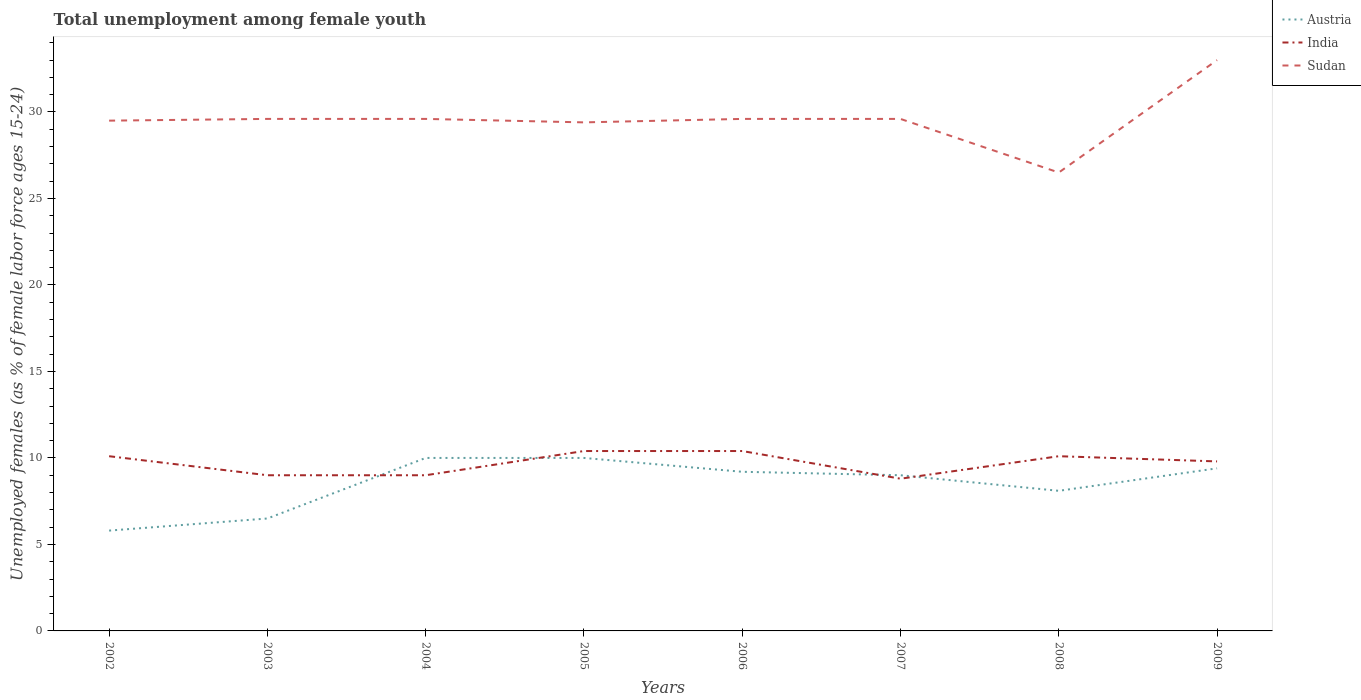How many different coloured lines are there?
Your response must be concise. 3. Is the number of lines equal to the number of legend labels?
Your answer should be very brief. Yes. Across all years, what is the maximum percentage of unemployed females in in Austria?
Offer a terse response. 5.8. What is the total percentage of unemployed females in in India in the graph?
Keep it short and to the point. 1.3. What is the difference between the highest and the second highest percentage of unemployed females in in Sudan?
Keep it short and to the point. 6.5. What is the difference between the highest and the lowest percentage of unemployed females in in India?
Keep it short and to the point. 5. What is the difference between two consecutive major ticks on the Y-axis?
Ensure brevity in your answer.  5. What is the title of the graph?
Provide a succinct answer. Total unemployment among female youth. Does "Japan" appear as one of the legend labels in the graph?
Your answer should be very brief. No. What is the label or title of the Y-axis?
Give a very brief answer. Unemployed females (as % of female labor force ages 15-24). What is the Unemployed females (as % of female labor force ages 15-24) of Austria in 2002?
Your answer should be compact. 5.8. What is the Unemployed females (as % of female labor force ages 15-24) in India in 2002?
Ensure brevity in your answer.  10.1. What is the Unemployed females (as % of female labor force ages 15-24) in Sudan in 2002?
Provide a short and direct response. 29.5. What is the Unemployed females (as % of female labor force ages 15-24) of India in 2003?
Provide a succinct answer. 9. What is the Unemployed females (as % of female labor force ages 15-24) of Sudan in 2003?
Provide a succinct answer. 29.6. What is the Unemployed females (as % of female labor force ages 15-24) of Austria in 2004?
Give a very brief answer. 10. What is the Unemployed females (as % of female labor force ages 15-24) in Sudan in 2004?
Ensure brevity in your answer.  29.6. What is the Unemployed females (as % of female labor force ages 15-24) of India in 2005?
Provide a short and direct response. 10.4. What is the Unemployed females (as % of female labor force ages 15-24) in Sudan in 2005?
Your answer should be very brief. 29.4. What is the Unemployed females (as % of female labor force ages 15-24) of Austria in 2006?
Offer a very short reply. 9.2. What is the Unemployed females (as % of female labor force ages 15-24) of India in 2006?
Provide a short and direct response. 10.4. What is the Unemployed females (as % of female labor force ages 15-24) of Sudan in 2006?
Your answer should be compact. 29.6. What is the Unemployed females (as % of female labor force ages 15-24) in India in 2007?
Provide a short and direct response. 8.8. What is the Unemployed females (as % of female labor force ages 15-24) of Sudan in 2007?
Offer a very short reply. 29.6. What is the Unemployed females (as % of female labor force ages 15-24) in Austria in 2008?
Your answer should be compact. 8.1. What is the Unemployed females (as % of female labor force ages 15-24) of India in 2008?
Make the answer very short. 10.1. What is the Unemployed females (as % of female labor force ages 15-24) in Sudan in 2008?
Your answer should be very brief. 26.5. What is the Unemployed females (as % of female labor force ages 15-24) of Austria in 2009?
Offer a terse response. 9.4. What is the Unemployed females (as % of female labor force ages 15-24) in India in 2009?
Offer a terse response. 9.8. What is the Unemployed females (as % of female labor force ages 15-24) of Sudan in 2009?
Offer a very short reply. 33. Across all years, what is the maximum Unemployed females (as % of female labor force ages 15-24) of Austria?
Give a very brief answer. 10. Across all years, what is the maximum Unemployed females (as % of female labor force ages 15-24) in India?
Your answer should be very brief. 10.4. Across all years, what is the minimum Unemployed females (as % of female labor force ages 15-24) in Austria?
Offer a terse response. 5.8. Across all years, what is the minimum Unemployed females (as % of female labor force ages 15-24) of India?
Keep it short and to the point. 8.8. Across all years, what is the minimum Unemployed females (as % of female labor force ages 15-24) in Sudan?
Your answer should be very brief. 26.5. What is the total Unemployed females (as % of female labor force ages 15-24) in India in the graph?
Keep it short and to the point. 77.6. What is the total Unemployed females (as % of female labor force ages 15-24) of Sudan in the graph?
Ensure brevity in your answer.  236.8. What is the difference between the Unemployed females (as % of female labor force ages 15-24) in India in 2002 and that in 2003?
Ensure brevity in your answer.  1.1. What is the difference between the Unemployed females (as % of female labor force ages 15-24) in Sudan in 2002 and that in 2003?
Make the answer very short. -0.1. What is the difference between the Unemployed females (as % of female labor force ages 15-24) in India in 2002 and that in 2004?
Your answer should be very brief. 1.1. What is the difference between the Unemployed females (as % of female labor force ages 15-24) in Sudan in 2002 and that in 2004?
Your response must be concise. -0.1. What is the difference between the Unemployed females (as % of female labor force ages 15-24) in Austria in 2002 and that in 2005?
Provide a short and direct response. -4.2. What is the difference between the Unemployed females (as % of female labor force ages 15-24) of Sudan in 2002 and that in 2006?
Offer a very short reply. -0.1. What is the difference between the Unemployed females (as % of female labor force ages 15-24) of Austria in 2002 and that in 2007?
Your response must be concise. -3.2. What is the difference between the Unemployed females (as % of female labor force ages 15-24) of Sudan in 2002 and that in 2007?
Offer a terse response. -0.1. What is the difference between the Unemployed females (as % of female labor force ages 15-24) of Austria in 2002 and that in 2008?
Offer a terse response. -2.3. What is the difference between the Unemployed females (as % of female labor force ages 15-24) in Austria in 2002 and that in 2009?
Make the answer very short. -3.6. What is the difference between the Unemployed females (as % of female labor force ages 15-24) in Sudan in 2002 and that in 2009?
Your answer should be very brief. -3.5. What is the difference between the Unemployed females (as % of female labor force ages 15-24) in Sudan in 2003 and that in 2004?
Keep it short and to the point. 0. What is the difference between the Unemployed females (as % of female labor force ages 15-24) in Austria in 2003 and that in 2005?
Make the answer very short. -3.5. What is the difference between the Unemployed females (as % of female labor force ages 15-24) in Sudan in 2003 and that in 2005?
Offer a terse response. 0.2. What is the difference between the Unemployed females (as % of female labor force ages 15-24) of India in 2003 and that in 2006?
Give a very brief answer. -1.4. What is the difference between the Unemployed females (as % of female labor force ages 15-24) of Sudan in 2003 and that in 2006?
Make the answer very short. 0. What is the difference between the Unemployed females (as % of female labor force ages 15-24) of India in 2003 and that in 2008?
Your response must be concise. -1.1. What is the difference between the Unemployed females (as % of female labor force ages 15-24) of Austria in 2003 and that in 2009?
Offer a terse response. -2.9. What is the difference between the Unemployed females (as % of female labor force ages 15-24) of Sudan in 2004 and that in 2005?
Give a very brief answer. 0.2. What is the difference between the Unemployed females (as % of female labor force ages 15-24) in Austria in 2004 and that in 2006?
Give a very brief answer. 0.8. What is the difference between the Unemployed females (as % of female labor force ages 15-24) in Sudan in 2004 and that in 2007?
Offer a terse response. 0. What is the difference between the Unemployed females (as % of female labor force ages 15-24) in Austria in 2004 and that in 2008?
Your answer should be very brief. 1.9. What is the difference between the Unemployed females (as % of female labor force ages 15-24) in India in 2004 and that in 2008?
Your response must be concise. -1.1. What is the difference between the Unemployed females (as % of female labor force ages 15-24) of Sudan in 2004 and that in 2008?
Your answer should be compact. 3.1. What is the difference between the Unemployed females (as % of female labor force ages 15-24) of Sudan in 2004 and that in 2009?
Offer a very short reply. -3.4. What is the difference between the Unemployed females (as % of female labor force ages 15-24) in India in 2005 and that in 2006?
Ensure brevity in your answer.  0. What is the difference between the Unemployed females (as % of female labor force ages 15-24) of Sudan in 2005 and that in 2006?
Make the answer very short. -0.2. What is the difference between the Unemployed females (as % of female labor force ages 15-24) in Austria in 2005 and that in 2007?
Your answer should be very brief. 1. What is the difference between the Unemployed females (as % of female labor force ages 15-24) of India in 2005 and that in 2007?
Ensure brevity in your answer.  1.6. What is the difference between the Unemployed females (as % of female labor force ages 15-24) of India in 2005 and that in 2008?
Your answer should be compact. 0.3. What is the difference between the Unemployed females (as % of female labor force ages 15-24) of Sudan in 2005 and that in 2008?
Provide a short and direct response. 2.9. What is the difference between the Unemployed females (as % of female labor force ages 15-24) in Sudan in 2005 and that in 2009?
Your answer should be compact. -3.6. What is the difference between the Unemployed females (as % of female labor force ages 15-24) of Austria in 2006 and that in 2008?
Ensure brevity in your answer.  1.1. What is the difference between the Unemployed females (as % of female labor force ages 15-24) of India in 2006 and that in 2008?
Your response must be concise. 0.3. What is the difference between the Unemployed females (as % of female labor force ages 15-24) in Sudan in 2006 and that in 2008?
Give a very brief answer. 3.1. What is the difference between the Unemployed females (as % of female labor force ages 15-24) in Austria in 2006 and that in 2009?
Give a very brief answer. -0.2. What is the difference between the Unemployed females (as % of female labor force ages 15-24) in India in 2006 and that in 2009?
Give a very brief answer. 0.6. What is the difference between the Unemployed females (as % of female labor force ages 15-24) of Sudan in 2006 and that in 2009?
Your answer should be compact. -3.4. What is the difference between the Unemployed females (as % of female labor force ages 15-24) of India in 2007 and that in 2008?
Offer a very short reply. -1.3. What is the difference between the Unemployed females (as % of female labor force ages 15-24) in Sudan in 2007 and that in 2008?
Provide a succinct answer. 3.1. What is the difference between the Unemployed females (as % of female labor force ages 15-24) of Austria in 2007 and that in 2009?
Give a very brief answer. -0.4. What is the difference between the Unemployed females (as % of female labor force ages 15-24) in India in 2007 and that in 2009?
Offer a very short reply. -1. What is the difference between the Unemployed females (as % of female labor force ages 15-24) of Austria in 2008 and that in 2009?
Ensure brevity in your answer.  -1.3. What is the difference between the Unemployed females (as % of female labor force ages 15-24) of India in 2008 and that in 2009?
Give a very brief answer. 0.3. What is the difference between the Unemployed females (as % of female labor force ages 15-24) of Sudan in 2008 and that in 2009?
Your response must be concise. -6.5. What is the difference between the Unemployed females (as % of female labor force ages 15-24) in Austria in 2002 and the Unemployed females (as % of female labor force ages 15-24) in Sudan in 2003?
Give a very brief answer. -23.8. What is the difference between the Unemployed females (as % of female labor force ages 15-24) of India in 2002 and the Unemployed females (as % of female labor force ages 15-24) of Sudan in 2003?
Your answer should be compact. -19.5. What is the difference between the Unemployed females (as % of female labor force ages 15-24) of Austria in 2002 and the Unemployed females (as % of female labor force ages 15-24) of Sudan in 2004?
Make the answer very short. -23.8. What is the difference between the Unemployed females (as % of female labor force ages 15-24) of India in 2002 and the Unemployed females (as % of female labor force ages 15-24) of Sudan in 2004?
Make the answer very short. -19.5. What is the difference between the Unemployed females (as % of female labor force ages 15-24) of Austria in 2002 and the Unemployed females (as % of female labor force ages 15-24) of Sudan in 2005?
Make the answer very short. -23.6. What is the difference between the Unemployed females (as % of female labor force ages 15-24) in India in 2002 and the Unemployed females (as % of female labor force ages 15-24) in Sudan in 2005?
Provide a succinct answer. -19.3. What is the difference between the Unemployed females (as % of female labor force ages 15-24) in Austria in 2002 and the Unemployed females (as % of female labor force ages 15-24) in Sudan in 2006?
Your response must be concise. -23.8. What is the difference between the Unemployed females (as % of female labor force ages 15-24) in India in 2002 and the Unemployed females (as % of female labor force ages 15-24) in Sudan in 2006?
Your answer should be very brief. -19.5. What is the difference between the Unemployed females (as % of female labor force ages 15-24) in Austria in 2002 and the Unemployed females (as % of female labor force ages 15-24) in India in 2007?
Provide a short and direct response. -3. What is the difference between the Unemployed females (as % of female labor force ages 15-24) in Austria in 2002 and the Unemployed females (as % of female labor force ages 15-24) in Sudan in 2007?
Your response must be concise. -23.8. What is the difference between the Unemployed females (as % of female labor force ages 15-24) of India in 2002 and the Unemployed females (as % of female labor force ages 15-24) of Sudan in 2007?
Provide a short and direct response. -19.5. What is the difference between the Unemployed females (as % of female labor force ages 15-24) of Austria in 2002 and the Unemployed females (as % of female labor force ages 15-24) of India in 2008?
Offer a very short reply. -4.3. What is the difference between the Unemployed females (as % of female labor force ages 15-24) in Austria in 2002 and the Unemployed females (as % of female labor force ages 15-24) in Sudan in 2008?
Give a very brief answer. -20.7. What is the difference between the Unemployed females (as % of female labor force ages 15-24) of India in 2002 and the Unemployed females (as % of female labor force ages 15-24) of Sudan in 2008?
Provide a short and direct response. -16.4. What is the difference between the Unemployed females (as % of female labor force ages 15-24) in Austria in 2002 and the Unemployed females (as % of female labor force ages 15-24) in Sudan in 2009?
Keep it short and to the point. -27.2. What is the difference between the Unemployed females (as % of female labor force ages 15-24) of India in 2002 and the Unemployed females (as % of female labor force ages 15-24) of Sudan in 2009?
Ensure brevity in your answer.  -22.9. What is the difference between the Unemployed females (as % of female labor force ages 15-24) of Austria in 2003 and the Unemployed females (as % of female labor force ages 15-24) of India in 2004?
Your answer should be compact. -2.5. What is the difference between the Unemployed females (as % of female labor force ages 15-24) of Austria in 2003 and the Unemployed females (as % of female labor force ages 15-24) of Sudan in 2004?
Your answer should be very brief. -23.1. What is the difference between the Unemployed females (as % of female labor force ages 15-24) in India in 2003 and the Unemployed females (as % of female labor force ages 15-24) in Sudan in 2004?
Ensure brevity in your answer.  -20.6. What is the difference between the Unemployed females (as % of female labor force ages 15-24) in Austria in 2003 and the Unemployed females (as % of female labor force ages 15-24) in Sudan in 2005?
Provide a short and direct response. -22.9. What is the difference between the Unemployed females (as % of female labor force ages 15-24) of India in 2003 and the Unemployed females (as % of female labor force ages 15-24) of Sudan in 2005?
Keep it short and to the point. -20.4. What is the difference between the Unemployed females (as % of female labor force ages 15-24) in Austria in 2003 and the Unemployed females (as % of female labor force ages 15-24) in Sudan in 2006?
Make the answer very short. -23.1. What is the difference between the Unemployed females (as % of female labor force ages 15-24) of India in 2003 and the Unemployed females (as % of female labor force ages 15-24) of Sudan in 2006?
Your answer should be compact. -20.6. What is the difference between the Unemployed females (as % of female labor force ages 15-24) of Austria in 2003 and the Unemployed females (as % of female labor force ages 15-24) of India in 2007?
Ensure brevity in your answer.  -2.3. What is the difference between the Unemployed females (as % of female labor force ages 15-24) of Austria in 2003 and the Unemployed females (as % of female labor force ages 15-24) of Sudan in 2007?
Offer a terse response. -23.1. What is the difference between the Unemployed females (as % of female labor force ages 15-24) of India in 2003 and the Unemployed females (as % of female labor force ages 15-24) of Sudan in 2007?
Offer a very short reply. -20.6. What is the difference between the Unemployed females (as % of female labor force ages 15-24) of India in 2003 and the Unemployed females (as % of female labor force ages 15-24) of Sudan in 2008?
Offer a terse response. -17.5. What is the difference between the Unemployed females (as % of female labor force ages 15-24) in Austria in 2003 and the Unemployed females (as % of female labor force ages 15-24) in Sudan in 2009?
Keep it short and to the point. -26.5. What is the difference between the Unemployed females (as % of female labor force ages 15-24) in Austria in 2004 and the Unemployed females (as % of female labor force ages 15-24) in India in 2005?
Offer a very short reply. -0.4. What is the difference between the Unemployed females (as % of female labor force ages 15-24) in Austria in 2004 and the Unemployed females (as % of female labor force ages 15-24) in Sudan in 2005?
Give a very brief answer. -19.4. What is the difference between the Unemployed females (as % of female labor force ages 15-24) in India in 2004 and the Unemployed females (as % of female labor force ages 15-24) in Sudan in 2005?
Make the answer very short. -20.4. What is the difference between the Unemployed females (as % of female labor force ages 15-24) in Austria in 2004 and the Unemployed females (as % of female labor force ages 15-24) in Sudan in 2006?
Your answer should be very brief. -19.6. What is the difference between the Unemployed females (as % of female labor force ages 15-24) in India in 2004 and the Unemployed females (as % of female labor force ages 15-24) in Sudan in 2006?
Your answer should be compact. -20.6. What is the difference between the Unemployed females (as % of female labor force ages 15-24) in Austria in 2004 and the Unemployed females (as % of female labor force ages 15-24) in India in 2007?
Provide a succinct answer. 1.2. What is the difference between the Unemployed females (as % of female labor force ages 15-24) in Austria in 2004 and the Unemployed females (as % of female labor force ages 15-24) in Sudan in 2007?
Your response must be concise. -19.6. What is the difference between the Unemployed females (as % of female labor force ages 15-24) of India in 2004 and the Unemployed females (as % of female labor force ages 15-24) of Sudan in 2007?
Provide a short and direct response. -20.6. What is the difference between the Unemployed females (as % of female labor force ages 15-24) of Austria in 2004 and the Unemployed females (as % of female labor force ages 15-24) of India in 2008?
Offer a very short reply. -0.1. What is the difference between the Unemployed females (as % of female labor force ages 15-24) in Austria in 2004 and the Unemployed females (as % of female labor force ages 15-24) in Sudan in 2008?
Offer a terse response. -16.5. What is the difference between the Unemployed females (as % of female labor force ages 15-24) of India in 2004 and the Unemployed females (as % of female labor force ages 15-24) of Sudan in 2008?
Your response must be concise. -17.5. What is the difference between the Unemployed females (as % of female labor force ages 15-24) in Austria in 2004 and the Unemployed females (as % of female labor force ages 15-24) in India in 2009?
Ensure brevity in your answer.  0.2. What is the difference between the Unemployed females (as % of female labor force ages 15-24) in Austria in 2005 and the Unemployed females (as % of female labor force ages 15-24) in India in 2006?
Ensure brevity in your answer.  -0.4. What is the difference between the Unemployed females (as % of female labor force ages 15-24) of Austria in 2005 and the Unemployed females (as % of female labor force ages 15-24) of Sudan in 2006?
Provide a succinct answer. -19.6. What is the difference between the Unemployed females (as % of female labor force ages 15-24) of India in 2005 and the Unemployed females (as % of female labor force ages 15-24) of Sudan in 2006?
Your answer should be compact. -19.2. What is the difference between the Unemployed females (as % of female labor force ages 15-24) in Austria in 2005 and the Unemployed females (as % of female labor force ages 15-24) in Sudan in 2007?
Provide a succinct answer. -19.6. What is the difference between the Unemployed females (as % of female labor force ages 15-24) in India in 2005 and the Unemployed females (as % of female labor force ages 15-24) in Sudan in 2007?
Provide a short and direct response. -19.2. What is the difference between the Unemployed females (as % of female labor force ages 15-24) in Austria in 2005 and the Unemployed females (as % of female labor force ages 15-24) in Sudan in 2008?
Your response must be concise. -16.5. What is the difference between the Unemployed females (as % of female labor force ages 15-24) of India in 2005 and the Unemployed females (as % of female labor force ages 15-24) of Sudan in 2008?
Give a very brief answer. -16.1. What is the difference between the Unemployed females (as % of female labor force ages 15-24) in Austria in 2005 and the Unemployed females (as % of female labor force ages 15-24) in India in 2009?
Make the answer very short. 0.2. What is the difference between the Unemployed females (as % of female labor force ages 15-24) of Austria in 2005 and the Unemployed females (as % of female labor force ages 15-24) of Sudan in 2009?
Ensure brevity in your answer.  -23. What is the difference between the Unemployed females (as % of female labor force ages 15-24) of India in 2005 and the Unemployed females (as % of female labor force ages 15-24) of Sudan in 2009?
Give a very brief answer. -22.6. What is the difference between the Unemployed females (as % of female labor force ages 15-24) in Austria in 2006 and the Unemployed females (as % of female labor force ages 15-24) in India in 2007?
Your answer should be compact. 0.4. What is the difference between the Unemployed females (as % of female labor force ages 15-24) in Austria in 2006 and the Unemployed females (as % of female labor force ages 15-24) in Sudan in 2007?
Your response must be concise. -20.4. What is the difference between the Unemployed females (as % of female labor force ages 15-24) of India in 2006 and the Unemployed females (as % of female labor force ages 15-24) of Sudan in 2007?
Provide a short and direct response. -19.2. What is the difference between the Unemployed females (as % of female labor force ages 15-24) in Austria in 2006 and the Unemployed females (as % of female labor force ages 15-24) in India in 2008?
Provide a succinct answer. -0.9. What is the difference between the Unemployed females (as % of female labor force ages 15-24) of Austria in 2006 and the Unemployed females (as % of female labor force ages 15-24) of Sudan in 2008?
Keep it short and to the point. -17.3. What is the difference between the Unemployed females (as % of female labor force ages 15-24) in India in 2006 and the Unemployed females (as % of female labor force ages 15-24) in Sudan in 2008?
Your answer should be very brief. -16.1. What is the difference between the Unemployed females (as % of female labor force ages 15-24) of Austria in 2006 and the Unemployed females (as % of female labor force ages 15-24) of Sudan in 2009?
Your answer should be compact. -23.8. What is the difference between the Unemployed females (as % of female labor force ages 15-24) of India in 2006 and the Unemployed females (as % of female labor force ages 15-24) of Sudan in 2009?
Make the answer very short. -22.6. What is the difference between the Unemployed females (as % of female labor force ages 15-24) of Austria in 2007 and the Unemployed females (as % of female labor force ages 15-24) of India in 2008?
Offer a terse response. -1.1. What is the difference between the Unemployed females (as % of female labor force ages 15-24) in Austria in 2007 and the Unemployed females (as % of female labor force ages 15-24) in Sudan in 2008?
Give a very brief answer. -17.5. What is the difference between the Unemployed females (as % of female labor force ages 15-24) of India in 2007 and the Unemployed females (as % of female labor force ages 15-24) of Sudan in 2008?
Provide a short and direct response. -17.7. What is the difference between the Unemployed females (as % of female labor force ages 15-24) in India in 2007 and the Unemployed females (as % of female labor force ages 15-24) in Sudan in 2009?
Your answer should be compact. -24.2. What is the difference between the Unemployed females (as % of female labor force ages 15-24) of Austria in 2008 and the Unemployed females (as % of female labor force ages 15-24) of India in 2009?
Provide a succinct answer. -1.7. What is the difference between the Unemployed females (as % of female labor force ages 15-24) in Austria in 2008 and the Unemployed females (as % of female labor force ages 15-24) in Sudan in 2009?
Provide a succinct answer. -24.9. What is the difference between the Unemployed females (as % of female labor force ages 15-24) in India in 2008 and the Unemployed females (as % of female labor force ages 15-24) in Sudan in 2009?
Offer a terse response. -22.9. What is the average Unemployed females (as % of female labor force ages 15-24) in Austria per year?
Provide a succinct answer. 8.5. What is the average Unemployed females (as % of female labor force ages 15-24) in Sudan per year?
Keep it short and to the point. 29.6. In the year 2002, what is the difference between the Unemployed females (as % of female labor force ages 15-24) in Austria and Unemployed females (as % of female labor force ages 15-24) in Sudan?
Ensure brevity in your answer.  -23.7. In the year 2002, what is the difference between the Unemployed females (as % of female labor force ages 15-24) in India and Unemployed females (as % of female labor force ages 15-24) in Sudan?
Your answer should be very brief. -19.4. In the year 2003, what is the difference between the Unemployed females (as % of female labor force ages 15-24) of Austria and Unemployed females (as % of female labor force ages 15-24) of Sudan?
Ensure brevity in your answer.  -23.1. In the year 2003, what is the difference between the Unemployed females (as % of female labor force ages 15-24) in India and Unemployed females (as % of female labor force ages 15-24) in Sudan?
Offer a terse response. -20.6. In the year 2004, what is the difference between the Unemployed females (as % of female labor force ages 15-24) of Austria and Unemployed females (as % of female labor force ages 15-24) of Sudan?
Your answer should be very brief. -19.6. In the year 2004, what is the difference between the Unemployed females (as % of female labor force ages 15-24) of India and Unemployed females (as % of female labor force ages 15-24) of Sudan?
Give a very brief answer. -20.6. In the year 2005, what is the difference between the Unemployed females (as % of female labor force ages 15-24) in Austria and Unemployed females (as % of female labor force ages 15-24) in Sudan?
Your response must be concise. -19.4. In the year 2005, what is the difference between the Unemployed females (as % of female labor force ages 15-24) in India and Unemployed females (as % of female labor force ages 15-24) in Sudan?
Ensure brevity in your answer.  -19. In the year 2006, what is the difference between the Unemployed females (as % of female labor force ages 15-24) in Austria and Unemployed females (as % of female labor force ages 15-24) in India?
Make the answer very short. -1.2. In the year 2006, what is the difference between the Unemployed females (as % of female labor force ages 15-24) in Austria and Unemployed females (as % of female labor force ages 15-24) in Sudan?
Offer a very short reply. -20.4. In the year 2006, what is the difference between the Unemployed females (as % of female labor force ages 15-24) in India and Unemployed females (as % of female labor force ages 15-24) in Sudan?
Keep it short and to the point. -19.2. In the year 2007, what is the difference between the Unemployed females (as % of female labor force ages 15-24) of Austria and Unemployed females (as % of female labor force ages 15-24) of India?
Offer a very short reply. 0.2. In the year 2007, what is the difference between the Unemployed females (as % of female labor force ages 15-24) of Austria and Unemployed females (as % of female labor force ages 15-24) of Sudan?
Offer a terse response. -20.6. In the year 2007, what is the difference between the Unemployed females (as % of female labor force ages 15-24) of India and Unemployed females (as % of female labor force ages 15-24) of Sudan?
Keep it short and to the point. -20.8. In the year 2008, what is the difference between the Unemployed females (as % of female labor force ages 15-24) of Austria and Unemployed females (as % of female labor force ages 15-24) of Sudan?
Provide a succinct answer. -18.4. In the year 2008, what is the difference between the Unemployed females (as % of female labor force ages 15-24) of India and Unemployed females (as % of female labor force ages 15-24) of Sudan?
Your answer should be compact. -16.4. In the year 2009, what is the difference between the Unemployed females (as % of female labor force ages 15-24) of Austria and Unemployed females (as % of female labor force ages 15-24) of India?
Keep it short and to the point. -0.4. In the year 2009, what is the difference between the Unemployed females (as % of female labor force ages 15-24) in Austria and Unemployed females (as % of female labor force ages 15-24) in Sudan?
Your response must be concise. -23.6. In the year 2009, what is the difference between the Unemployed females (as % of female labor force ages 15-24) in India and Unemployed females (as % of female labor force ages 15-24) in Sudan?
Your response must be concise. -23.2. What is the ratio of the Unemployed females (as % of female labor force ages 15-24) in Austria in 2002 to that in 2003?
Provide a short and direct response. 0.89. What is the ratio of the Unemployed females (as % of female labor force ages 15-24) in India in 2002 to that in 2003?
Your response must be concise. 1.12. What is the ratio of the Unemployed females (as % of female labor force ages 15-24) of Sudan in 2002 to that in 2003?
Keep it short and to the point. 1. What is the ratio of the Unemployed females (as % of female labor force ages 15-24) in Austria in 2002 to that in 2004?
Make the answer very short. 0.58. What is the ratio of the Unemployed females (as % of female labor force ages 15-24) in India in 2002 to that in 2004?
Your response must be concise. 1.12. What is the ratio of the Unemployed females (as % of female labor force ages 15-24) of Sudan in 2002 to that in 2004?
Give a very brief answer. 1. What is the ratio of the Unemployed females (as % of female labor force ages 15-24) of Austria in 2002 to that in 2005?
Make the answer very short. 0.58. What is the ratio of the Unemployed females (as % of female labor force ages 15-24) in India in 2002 to that in 2005?
Offer a very short reply. 0.97. What is the ratio of the Unemployed females (as % of female labor force ages 15-24) of Sudan in 2002 to that in 2005?
Keep it short and to the point. 1. What is the ratio of the Unemployed females (as % of female labor force ages 15-24) in Austria in 2002 to that in 2006?
Make the answer very short. 0.63. What is the ratio of the Unemployed females (as % of female labor force ages 15-24) in India in 2002 to that in 2006?
Provide a succinct answer. 0.97. What is the ratio of the Unemployed females (as % of female labor force ages 15-24) in Austria in 2002 to that in 2007?
Your response must be concise. 0.64. What is the ratio of the Unemployed females (as % of female labor force ages 15-24) of India in 2002 to that in 2007?
Provide a short and direct response. 1.15. What is the ratio of the Unemployed females (as % of female labor force ages 15-24) of Austria in 2002 to that in 2008?
Provide a succinct answer. 0.72. What is the ratio of the Unemployed females (as % of female labor force ages 15-24) in Sudan in 2002 to that in 2008?
Provide a short and direct response. 1.11. What is the ratio of the Unemployed females (as % of female labor force ages 15-24) in Austria in 2002 to that in 2009?
Ensure brevity in your answer.  0.62. What is the ratio of the Unemployed females (as % of female labor force ages 15-24) in India in 2002 to that in 2009?
Offer a terse response. 1.03. What is the ratio of the Unemployed females (as % of female labor force ages 15-24) in Sudan in 2002 to that in 2009?
Your answer should be very brief. 0.89. What is the ratio of the Unemployed females (as % of female labor force ages 15-24) in Austria in 2003 to that in 2004?
Your response must be concise. 0.65. What is the ratio of the Unemployed females (as % of female labor force ages 15-24) of India in 2003 to that in 2004?
Your answer should be very brief. 1. What is the ratio of the Unemployed females (as % of female labor force ages 15-24) in Austria in 2003 to that in 2005?
Give a very brief answer. 0.65. What is the ratio of the Unemployed females (as % of female labor force ages 15-24) of India in 2003 to that in 2005?
Your answer should be very brief. 0.87. What is the ratio of the Unemployed females (as % of female labor force ages 15-24) in Sudan in 2003 to that in 2005?
Provide a short and direct response. 1.01. What is the ratio of the Unemployed females (as % of female labor force ages 15-24) of Austria in 2003 to that in 2006?
Your answer should be compact. 0.71. What is the ratio of the Unemployed females (as % of female labor force ages 15-24) in India in 2003 to that in 2006?
Offer a terse response. 0.87. What is the ratio of the Unemployed females (as % of female labor force ages 15-24) of Austria in 2003 to that in 2007?
Provide a succinct answer. 0.72. What is the ratio of the Unemployed females (as % of female labor force ages 15-24) of India in 2003 to that in 2007?
Your answer should be very brief. 1.02. What is the ratio of the Unemployed females (as % of female labor force ages 15-24) in Sudan in 2003 to that in 2007?
Keep it short and to the point. 1. What is the ratio of the Unemployed females (as % of female labor force ages 15-24) in Austria in 2003 to that in 2008?
Provide a succinct answer. 0.8. What is the ratio of the Unemployed females (as % of female labor force ages 15-24) of India in 2003 to that in 2008?
Offer a terse response. 0.89. What is the ratio of the Unemployed females (as % of female labor force ages 15-24) of Sudan in 2003 to that in 2008?
Give a very brief answer. 1.12. What is the ratio of the Unemployed females (as % of female labor force ages 15-24) in Austria in 2003 to that in 2009?
Keep it short and to the point. 0.69. What is the ratio of the Unemployed females (as % of female labor force ages 15-24) in India in 2003 to that in 2009?
Make the answer very short. 0.92. What is the ratio of the Unemployed females (as % of female labor force ages 15-24) in Sudan in 2003 to that in 2009?
Your answer should be compact. 0.9. What is the ratio of the Unemployed females (as % of female labor force ages 15-24) in India in 2004 to that in 2005?
Ensure brevity in your answer.  0.87. What is the ratio of the Unemployed females (as % of female labor force ages 15-24) in Sudan in 2004 to that in 2005?
Provide a short and direct response. 1.01. What is the ratio of the Unemployed females (as % of female labor force ages 15-24) of Austria in 2004 to that in 2006?
Your answer should be compact. 1.09. What is the ratio of the Unemployed females (as % of female labor force ages 15-24) of India in 2004 to that in 2006?
Ensure brevity in your answer.  0.87. What is the ratio of the Unemployed females (as % of female labor force ages 15-24) of Sudan in 2004 to that in 2006?
Provide a short and direct response. 1. What is the ratio of the Unemployed females (as % of female labor force ages 15-24) of India in 2004 to that in 2007?
Give a very brief answer. 1.02. What is the ratio of the Unemployed females (as % of female labor force ages 15-24) in Austria in 2004 to that in 2008?
Keep it short and to the point. 1.23. What is the ratio of the Unemployed females (as % of female labor force ages 15-24) in India in 2004 to that in 2008?
Keep it short and to the point. 0.89. What is the ratio of the Unemployed females (as % of female labor force ages 15-24) in Sudan in 2004 to that in 2008?
Your answer should be very brief. 1.12. What is the ratio of the Unemployed females (as % of female labor force ages 15-24) of Austria in 2004 to that in 2009?
Keep it short and to the point. 1.06. What is the ratio of the Unemployed females (as % of female labor force ages 15-24) of India in 2004 to that in 2009?
Offer a terse response. 0.92. What is the ratio of the Unemployed females (as % of female labor force ages 15-24) in Sudan in 2004 to that in 2009?
Give a very brief answer. 0.9. What is the ratio of the Unemployed females (as % of female labor force ages 15-24) in Austria in 2005 to that in 2006?
Offer a terse response. 1.09. What is the ratio of the Unemployed females (as % of female labor force ages 15-24) in India in 2005 to that in 2006?
Make the answer very short. 1. What is the ratio of the Unemployed females (as % of female labor force ages 15-24) in Austria in 2005 to that in 2007?
Your answer should be compact. 1.11. What is the ratio of the Unemployed females (as % of female labor force ages 15-24) of India in 2005 to that in 2007?
Your answer should be very brief. 1.18. What is the ratio of the Unemployed females (as % of female labor force ages 15-24) of Sudan in 2005 to that in 2007?
Offer a terse response. 0.99. What is the ratio of the Unemployed females (as % of female labor force ages 15-24) of Austria in 2005 to that in 2008?
Give a very brief answer. 1.23. What is the ratio of the Unemployed females (as % of female labor force ages 15-24) in India in 2005 to that in 2008?
Give a very brief answer. 1.03. What is the ratio of the Unemployed females (as % of female labor force ages 15-24) in Sudan in 2005 to that in 2008?
Ensure brevity in your answer.  1.11. What is the ratio of the Unemployed females (as % of female labor force ages 15-24) in Austria in 2005 to that in 2009?
Provide a succinct answer. 1.06. What is the ratio of the Unemployed females (as % of female labor force ages 15-24) of India in 2005 to that in 2009?
Make the answer very short. 1.06. What is the ratio of the Unemployed females (as % of female labor force ages 15-24) of Sudan in 2005 to that in 2009?
Provide a succinct answer. 0.89. What is the ratio of the Unemployed females (as % of female labor force ages 15-24) of Austria in 2006 to that in 2007?
Offer a terse response. 1.02. What is the ratio of the Unemployed females (as % of female labor force ages 15-24) of India in 2006 to that in 2007?
Provide a short and direct response. 1.18. What is the ratio of the Unemployed females (as % of female labor force ages 15-24) in Austria in 2006 to that in 2008?
Give a very brief answer. 1.14. What is the ratio of the Unemployed females (as % of female labor force ages 15-24) in India in 2006 to that in 2008?
Offer a very short reply. 1.03. What is the ratio of the Unemployed females (as % of female labor force ages 15-24) in Sudan in 2006 to that in 2008?
Your response must be concise. 1.12. What is the ratio of the Unemployed females (as % of female labor force ages 15-24) of Austria in 2006 to that in 2009?
Provide a succinct answer. 0.98. What is the ratio of the Unemployed females (as % of female labor force ages 15-24) of India in 2006 to that in 2009?
Give a very brief answer. 1.06. What is the ratio of the Unemployed females (as % of female labor force ages 15-24) in Sudan in 2006 to that in 2009?
Ensure brevity in your answer.  0.9. What is the ratio of the Unemployed females (as % of female labor force ages 15-24) in India in 2007 to that in 2008?
Provide a short and direct response. 0.87. What is the ratio of the Unemployed females (as % of female labor force ages 15-24) in Sudan in 2007 to that in 2008?
Your answer should be compact. 1.12. What is the ratio of the Unemployed females (as % of female labor force ages 15-24) of Austria in 2007 to that in 2009?
Your response must be concise. 0.96. What is the ratio of the Unemployed females (as % of female labor force ages 15-24) in India in 2007 to that in 2009?
Ensure brevity in your answer.  0.9. What is the ratio of the Unemployed females (as % of female labor force ages 15-24) in Sudan in 2007 to that in 2009?
Your answer should be very brief. 0.9. What is the ratio of the Unemployed females (as % of female labor force ages 15-24) in Austria in 2008 to that in 2009?
Your answer should be compact. 0.86. What is the ratio of the Unemployed females (as % of female labor force ages 15-24) in India in 2008 to that in 2009?
Your response must be concise. 1.03. What is the ratio of the Unemployed females (as % of female labor force ages 15-24) in Sudan in 2008 to that in 2009?
Your answer should be compact. 0.8. What is the difference between the highest and the second highest Unemployed females (as % of female labor force ages 15-24) in Austria?
Make the answer very short. 0. What is the difference between the highest and the second highest Unemployed females (as % of female labor force ages 15-24) of Sudan?
Offer a very short reply. 3.4. What is the difference between the highest and the lowest Unemployed females (as % of female labor force ages 15-24) in Austria?
Make the answer very short. 4.2. What is the difference between the highest and the lowest Unemployed females (as % of female labor force ages 15-24) of India?
Make the answer very short. 1.6. What is the difference between the highest and the lowest Unemployed females (as % of female labor force ages 15-24) in Sudan?
Keep it short and to the point. 6.5. 